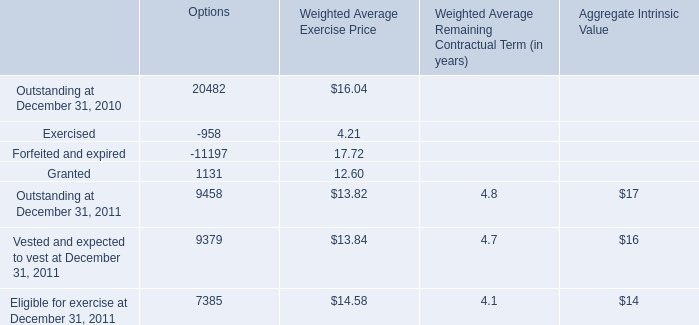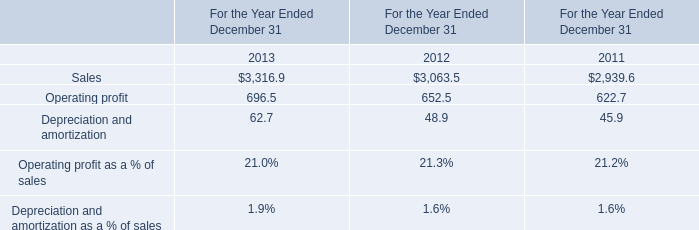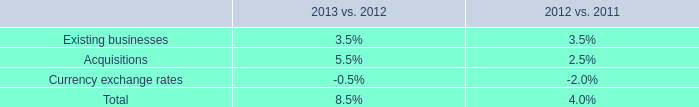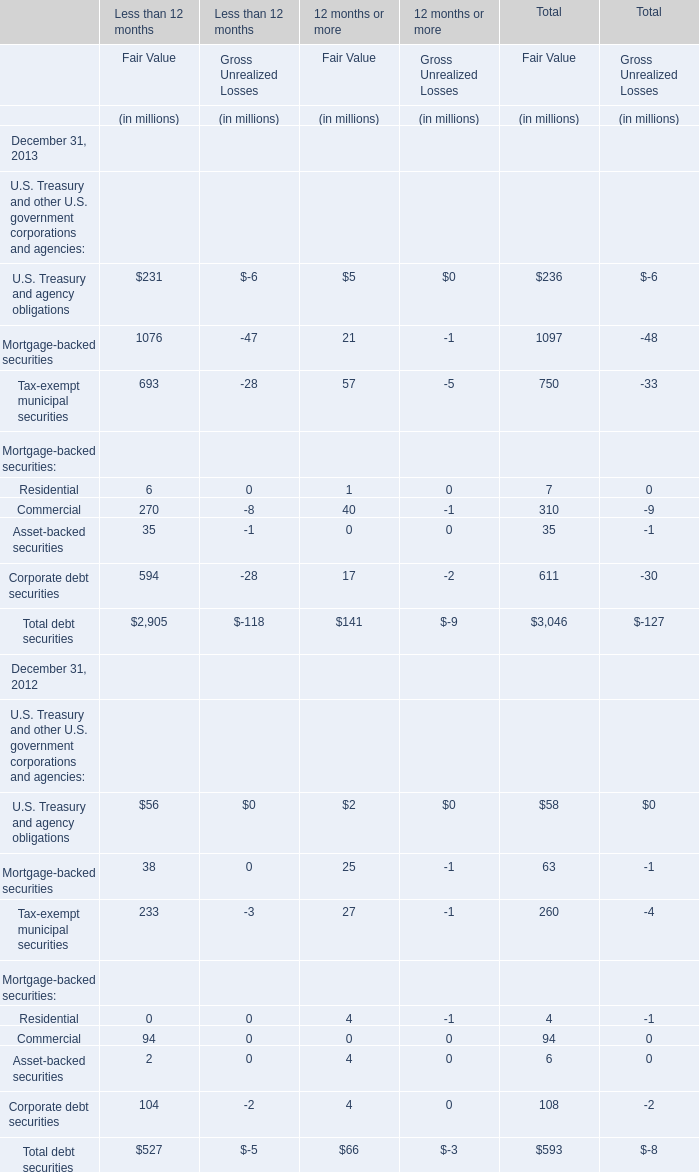If Commercial for Fair Value of Total develops with the same increasing rate in 2013, what will it reach in 2014? (in million) 
Computations: (310 * (1 + ((310 - 94) / 94)))
Answer: 1022.34043. 